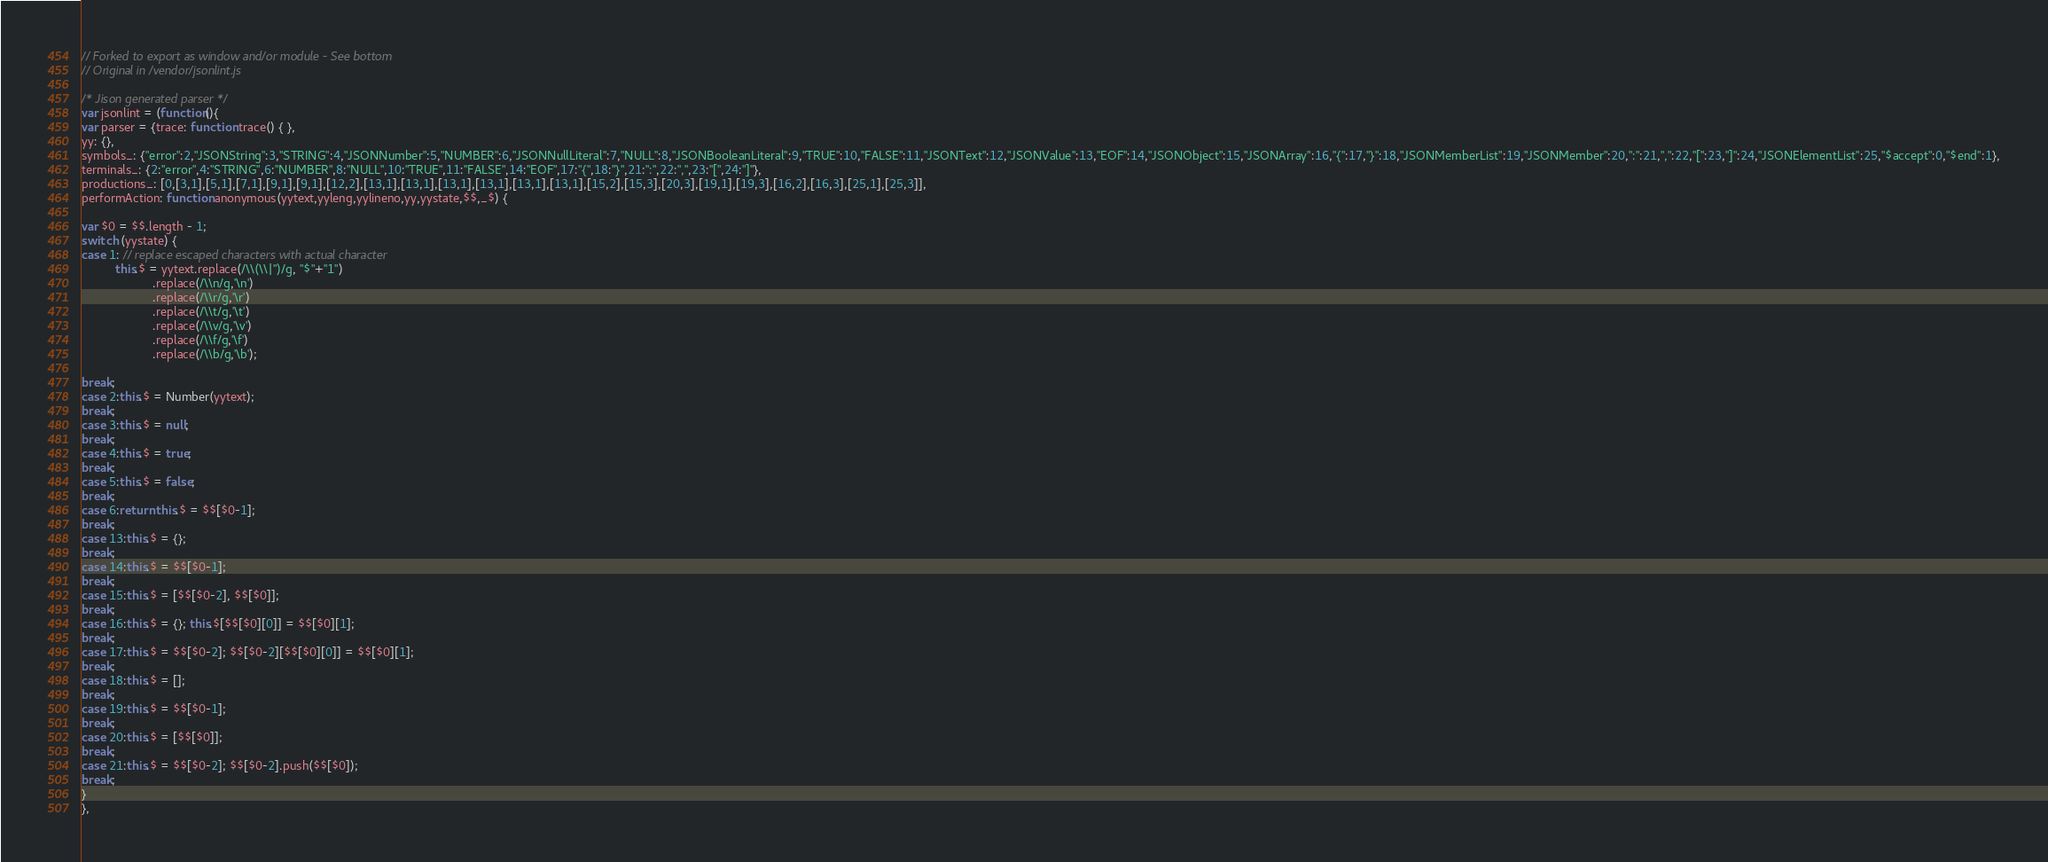Convert code to text. <code><loc_0><loc_0><loc_500><loc_500><_JavaScript_>// Forked to export as window and/or module - See bottom
// Original in /vendor/jsonlint.js

/* Jison generated parser */
var jsonlint = (function(){
var parser = {trace: function trace() { },
yy: {},
symbols_: {"error":2,"JSONString":3,"STRING":4,"JSONNumber":5,"NUMBER":6,"JSONNullLiteral":7,"NULL":8,"JSONBooleanLiteral":9,"TRUE":10,"FALSE":11,"JSONText":12,"JSONValue":13,"EOF":14,"JSONObject":15,"JSONArray":16,"{":17,"}":18,"JSONMemberList":19,"JSONMember":20,":":21,",":22,"[":23,"]":24,"JSONElementList":25,"$accept":0,"$end":1},
terminals_: {2:"error",4:"STRING",6:"NUMBER",8:"NULL",10:"TRUE",11:"FALSE",14:"EOF",17:"{",18:"}",21:":",22:",",23:"[",24:"]"},
productions_: [0,[3,1],[5,1],[7,1],[9,1],[9,1],[12,2],[13,1],[13,1],[13,1],[13,1],[13,1],[13,1],[15,2],[15,3],[20,3],[19,1],[19,3],[16,2],[16,3],[25,1],[25,3]],
performAction: function anonymous(yytext,yyleng,yylineno,yy,yystate,$$,_$) {

var $0 = $$.length - 1;
switch (yystate) {
case 1: // replace escaped characters with actual character
          this.$ = yytext.replace(/\\(\\|")/g, "$"+"1")
                     .replace(/\\n/g,'\n')
                     .replace(/\\r/g,'\r')
                     .replace(/\\t/g,'\t')
                     .replace(/\\v/g,'\v')
                     .replace(/\\f/g,'\f')
                     .replace(/\\b/g,'\b');

break;
case 2:this.$ = Number(yytext);
break;
case 3:this.$ = null;
break;
case 4:this.$ = true;
break;
case 5:this.$ = false;
break;
case 6:return this.$ = $$[$0-1];
break;
case 13:this.$ = {};
break;
case 14:this.$ = $$[$0-1];
break;
case 15:this.$ = [$$[$0-2], $$[$0]];
break;
case 16:this.$ = {}; this.$[$$[$0][0]] = $$[$0][1];
break;
case 17:this.$ = $$[$0-2]; $$[$0-2][$$[$0][0]] = $$[$0][1];
break;
case 18:this.$ = [];
break;
case 19:this.$ = $$[$0-1];
break;
case 20:this.$ = [$$[$0]];
break;
case 21:this.$ = $$[$0-2]; $$[$0-2].push($$[$0]);
break;
}
},</code> 